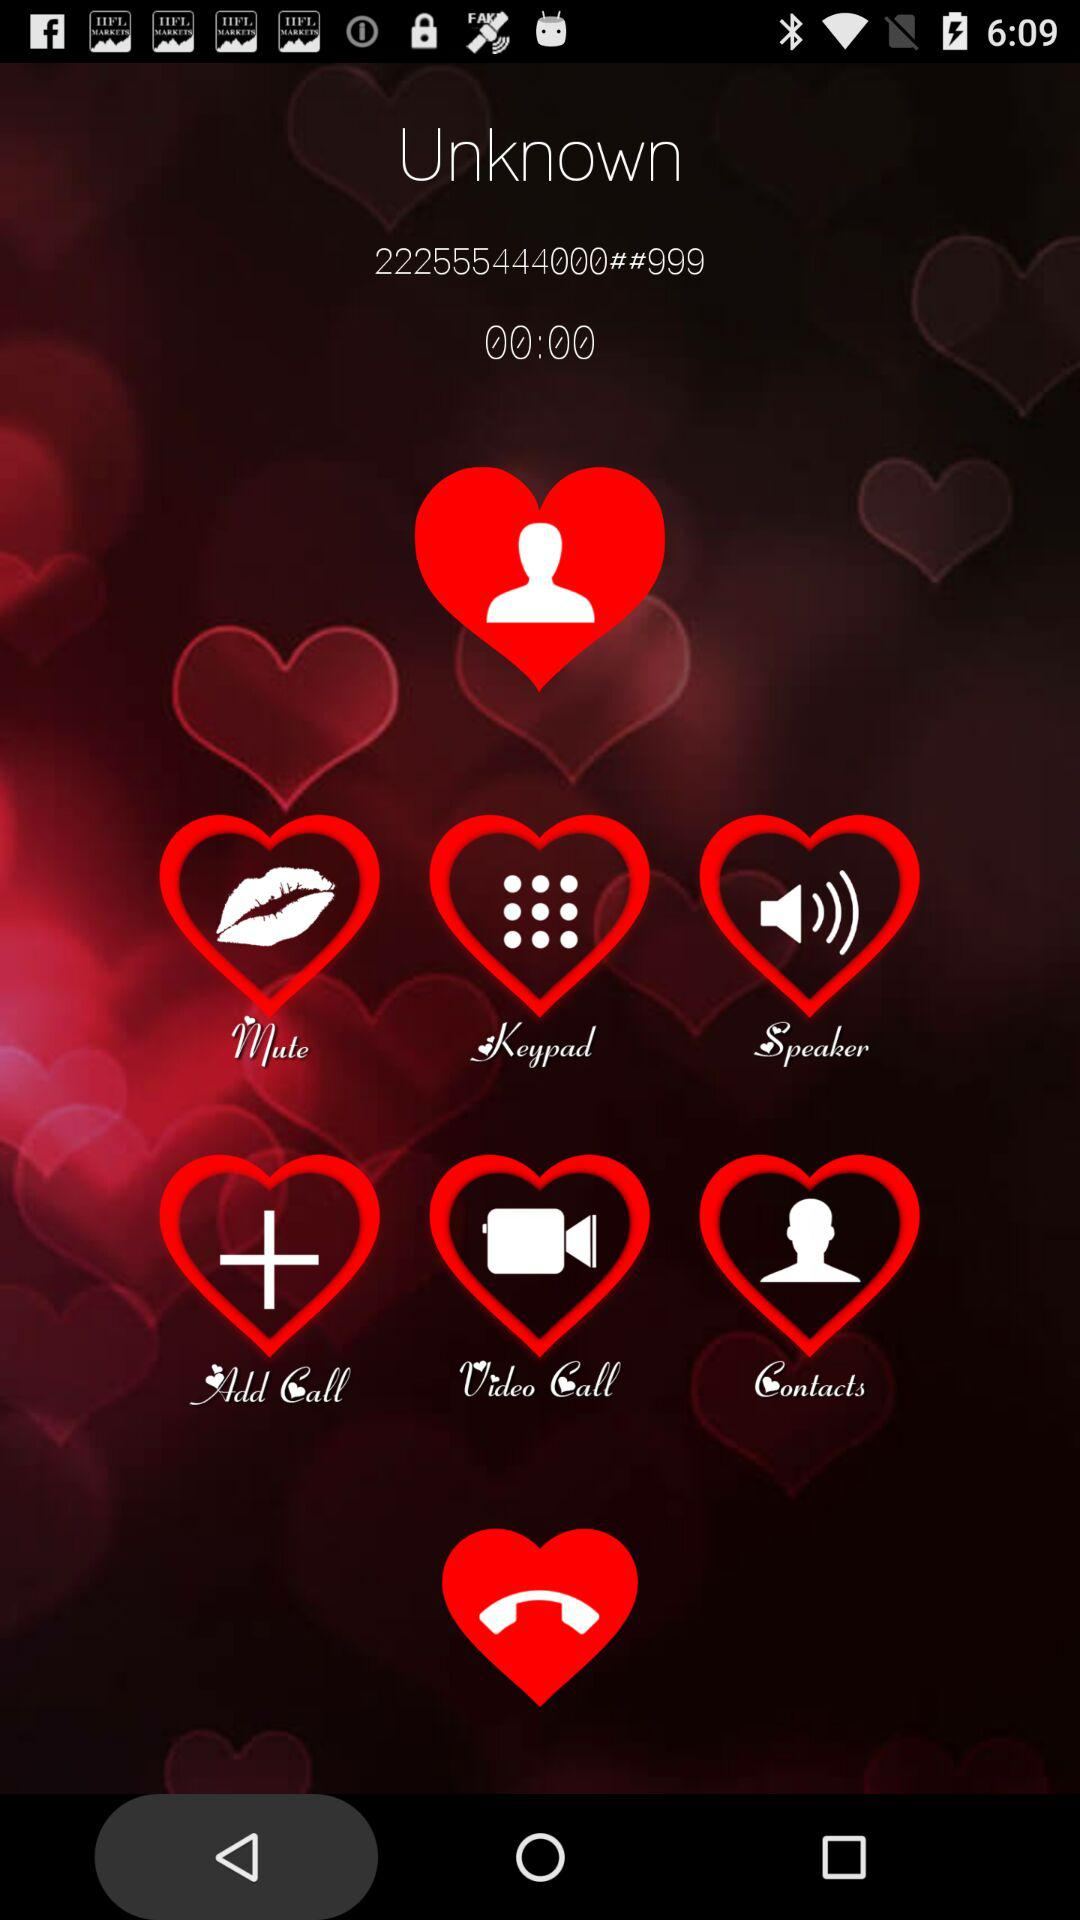What is the given phone number? The given phone number is 222555444000##999. 